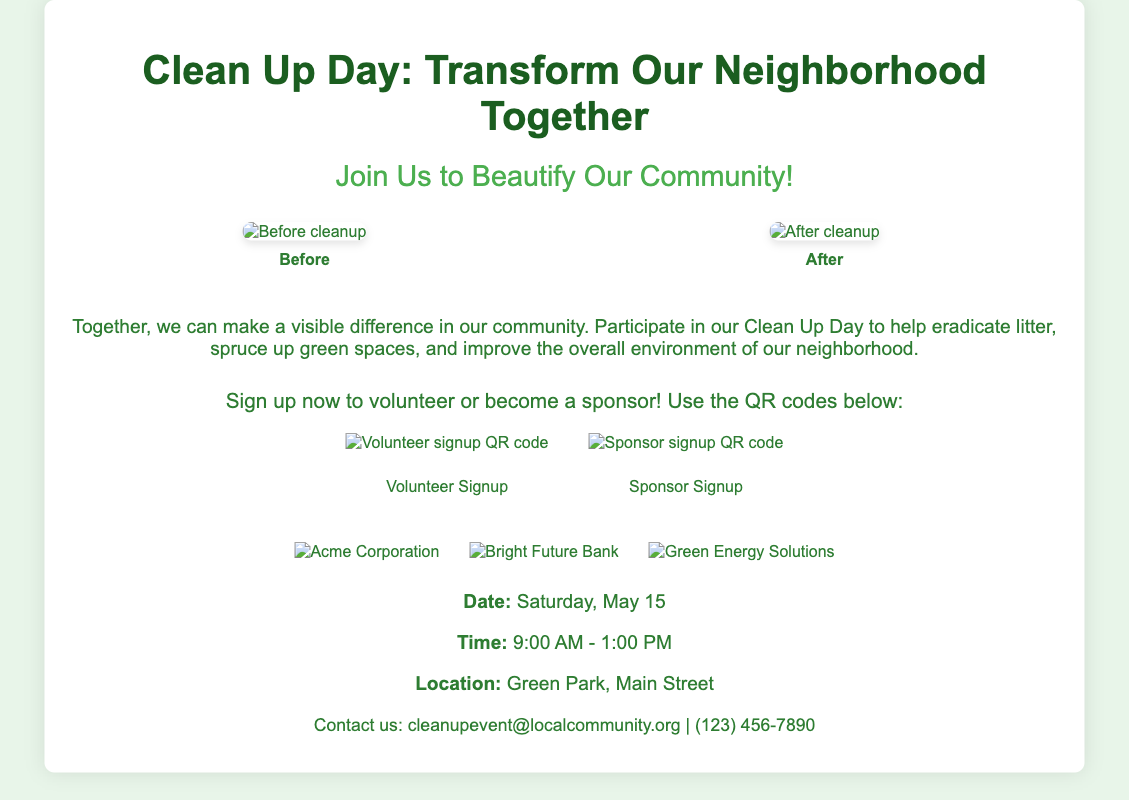What is the date of the event? The date of the event is specified in the event details section of the document.
Answer: Saturday, May 15 What time does the Clean Up Day start? The start time is mentioned in the event details section.
Answer: 9:00 AM Where is the event taking place? The location is provided in the event details section.
Answer: Green Park, Main Street What is the main purpose of the Clean Up Day? The description section outlines the purpose of the event.
Answer: Beautify our community How many sponsor logos are displayed? Counting the logos in the sponsors section gives the total number.
Answer: Three What can participants sign up for using the QR codes? The QR codes allow sign-ups for two different opportunities mentioned in the CTA.
Answer: Volunteer or Sponsor What is the color scheme used for the headings? The color of the headings can be found in the CSS styles referenced in the document.
Answer: Dark green What type of images are showcased in the photos section? The photos section highlights specific types of images before and after the cleanup efforts.
Answer: Before and After What is the contact email provided in the document? The contact email is mentioned in the contact section of the document.
Answer: cleanupevent@localcommunity.org 